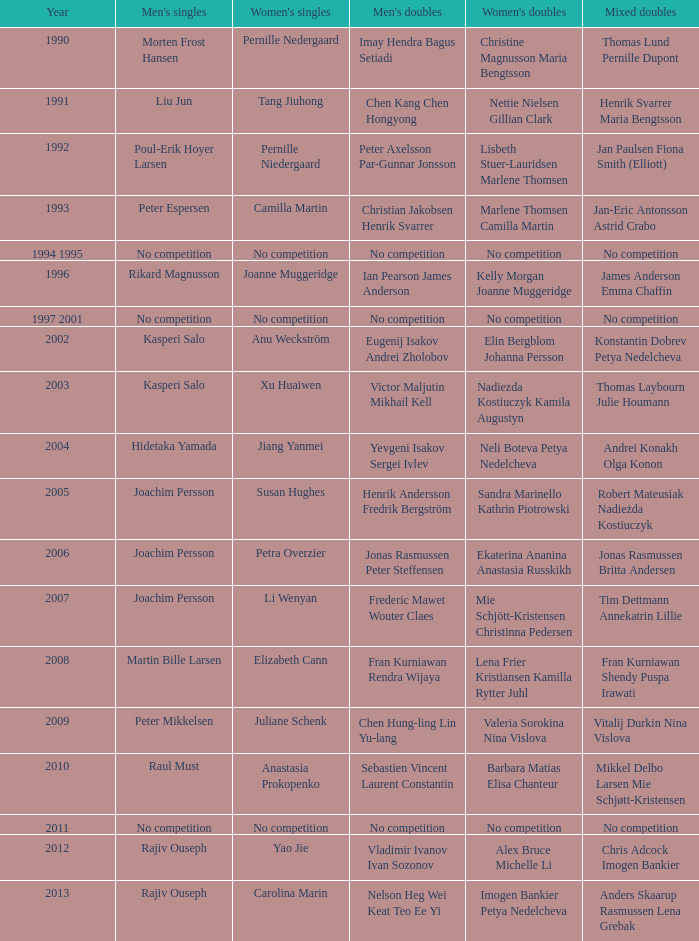In which year did carolina marin secure the women's singles title? 2013.0. 